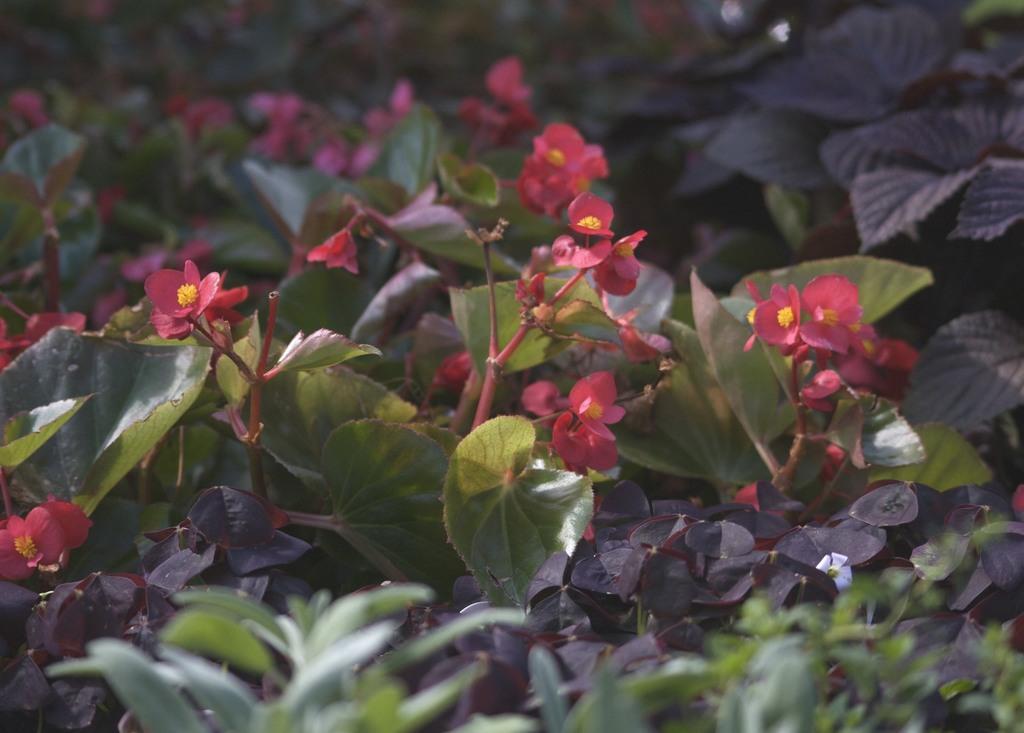Describe this image in one or two sentences. In this image we can see some plants and flowers. 